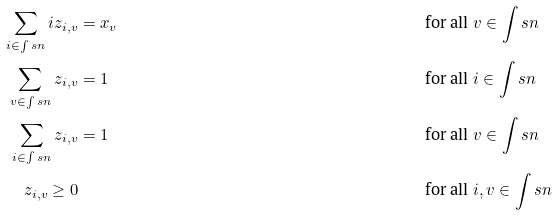Convert formula to latex. <formula><loc_0><loc_0><loc_500><loc_500>\sum _ { i \in \int s { n } } i z _ { i , v } & = x _ { v } & & \text { for all } v \in \int s { n } \\ \sum _ { v \in \int s { n } } z _ { i , v } & = 1 & & \text { for all } i \in \int s { n } \\ \sum _ { i \in \int s { n } } z _ { i , v } & = 1 & & \text { for all } v \in \int s { n } \\ z _ { i , v } \geq 0 & & & \text { for all } i , v \in \int s { n }</formula> 